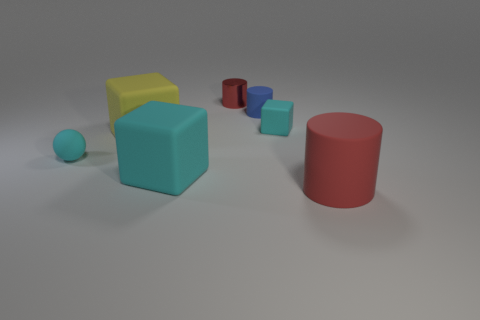What is the small object that is left of the blue matte cylinder and to the right of the sphere made of?
Provide a short and direct response. Metal. There is a cyan matte object that is the same size as the yellow matte thing; what shape is it?
Your answer should be very brief. Cube. There is a matte cylinder that is on the left side of the cylinder that is in front of the tiny object on the left side of the shiny cylinder; what is its color?
Your response must be concise. Blue. What number of things are either big rubber cubes that are on the right side of the yellow thing or cylinders?
Ensure brevity in your answer.  4. There is another cube that is the same size as the yellow rubber cube; what is its material?
Your answer should be compact. Rubber. The block on the right side of the red object that is behind the cyan matte object left of the large yellow rubber thing is made of what material?
Provide a succinct answer. Rubber. What color is the tiny metal object?
Provide a succinct answer. Red. How many tiny things are red matte things or purple matte things?
Your response must be concise. 0. What material is the tiny cylinder that is the same color as the large cylinder?
Give a very brief answer. Metal. Is the cyan object that is behind the yellow rubber object made of the same material as the cylinder in front of the small cyan rubber sphere?
Ensure brevity in your answer.  Yes. 